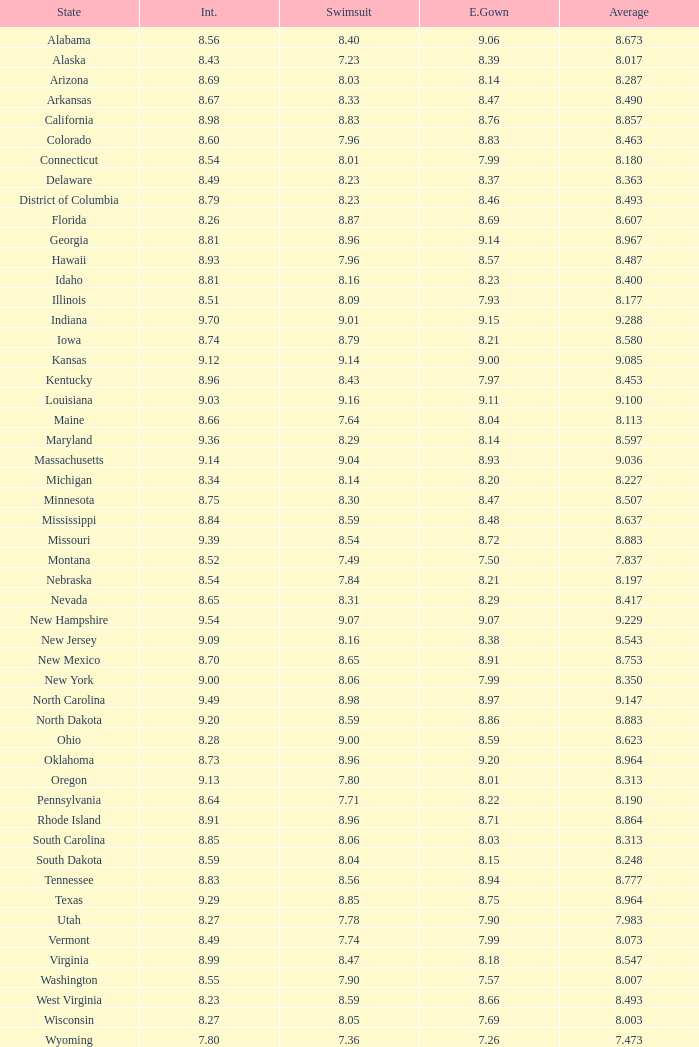Name the total number of swimsuits for evening gowns less than 8.21 and average of 8.453 with interview less than 9.09 1.0. 